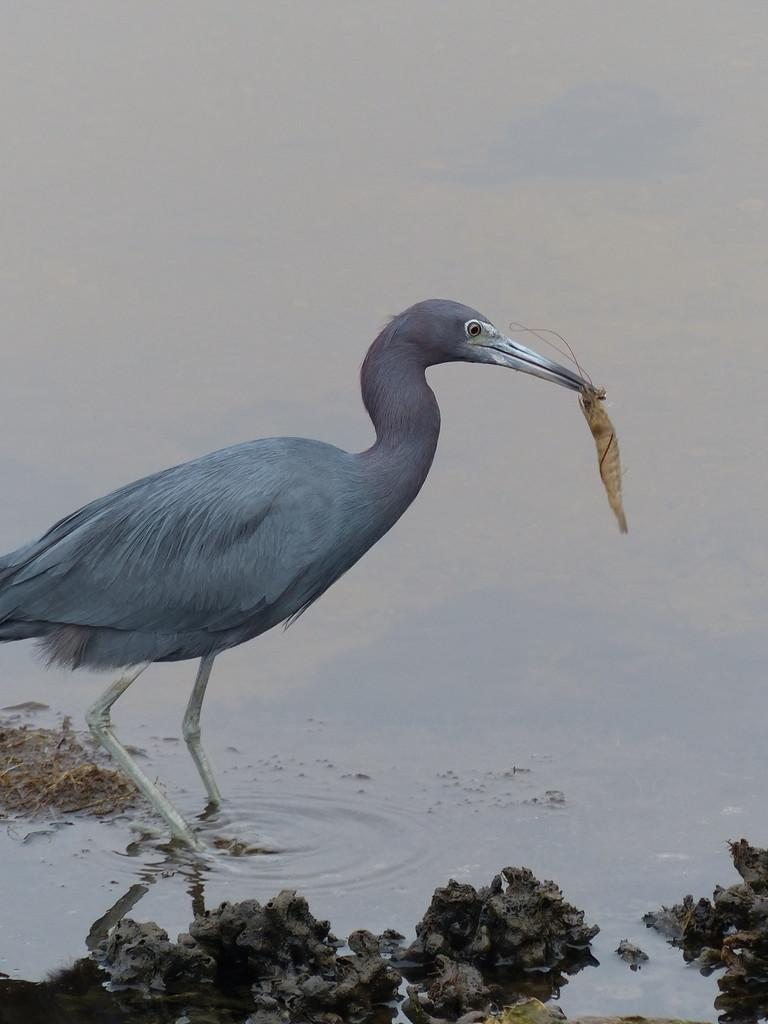What is the main subject in the center of the image? There is a crane in the center of the image. What is the crane holding in its beak? The crane is holding some dry leaves. What type of natural environment is depicted at the bottom of the image? There is a beach at the bottom of the image. What type of vegetation can be seen in the image? There is grass in the image. What type of ground surface is present in the image? There are small stones in the image. What type of polish is the crane using to clean its feathers in the image? There is no indication in the image that the crane is using any polish to clean its feathers. What is the crane's fear of in the image? There is no indication in the image that the crane is experiencing any fear. 